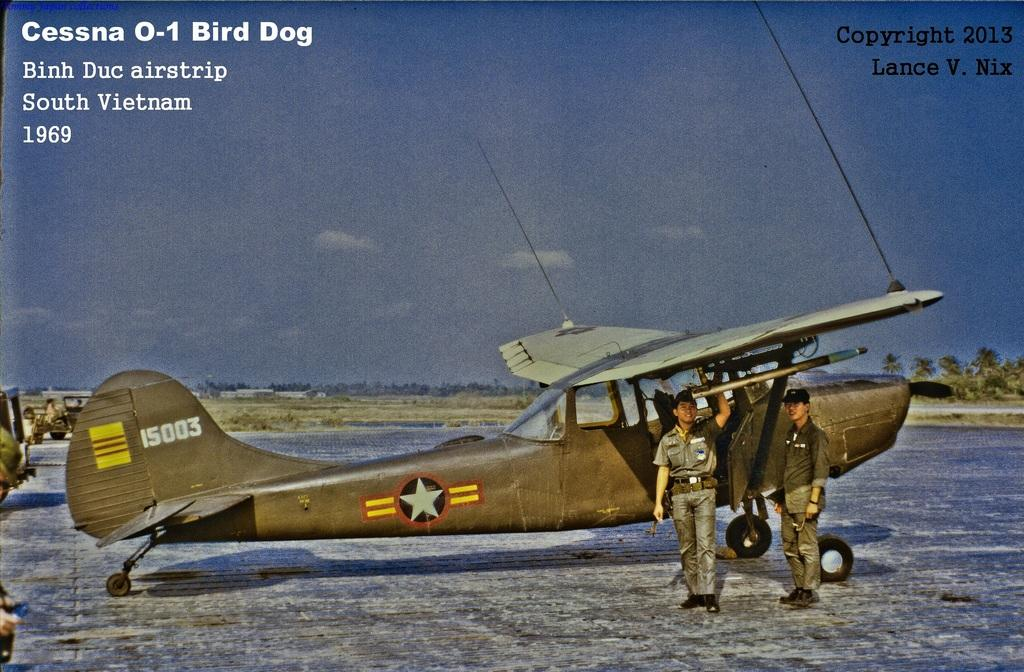Provide a one-sentence caption for the provided image. A postcard with the Cessna 0-1 Bird Dog on the front. 